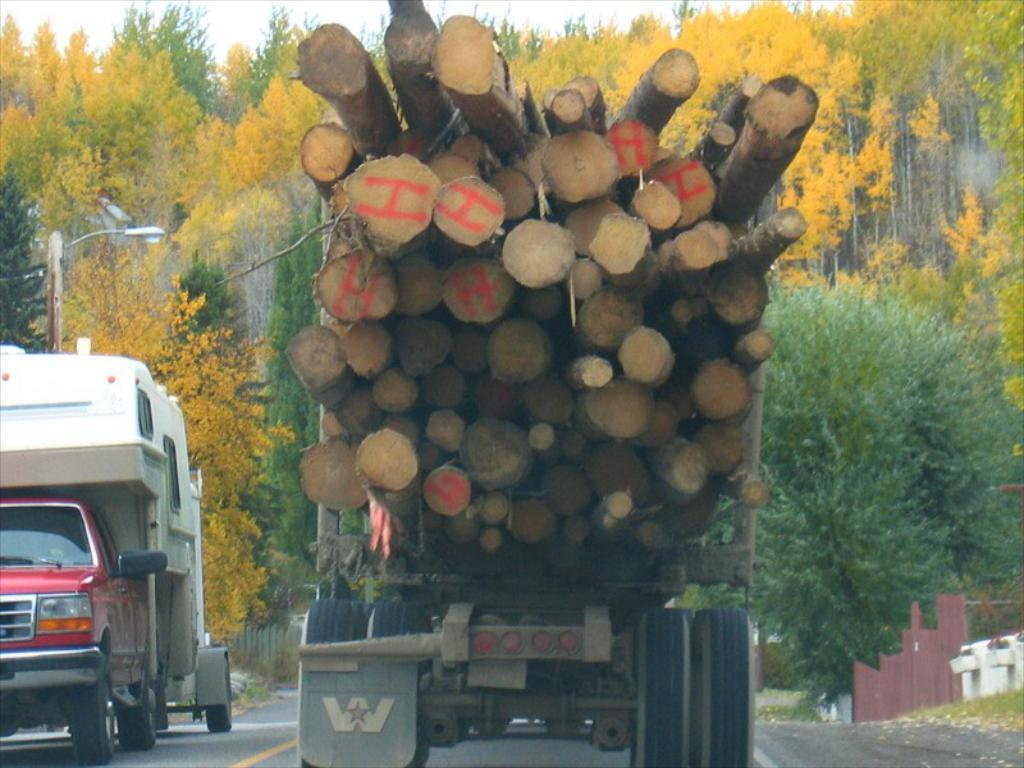What is the main feature of the image? There is a road in the image. What vehicles can be seen on the road? There are trucks in the image. What object is made of wood in the image? There is a log of wood in the image. What type of vegetation is visible in the background? There are trees in the background of the image. What type of lighting is present in the image? There is a street light in the image. What type of brush is used to paint the pickle in the image? There is no brush or pickle present in the image. 